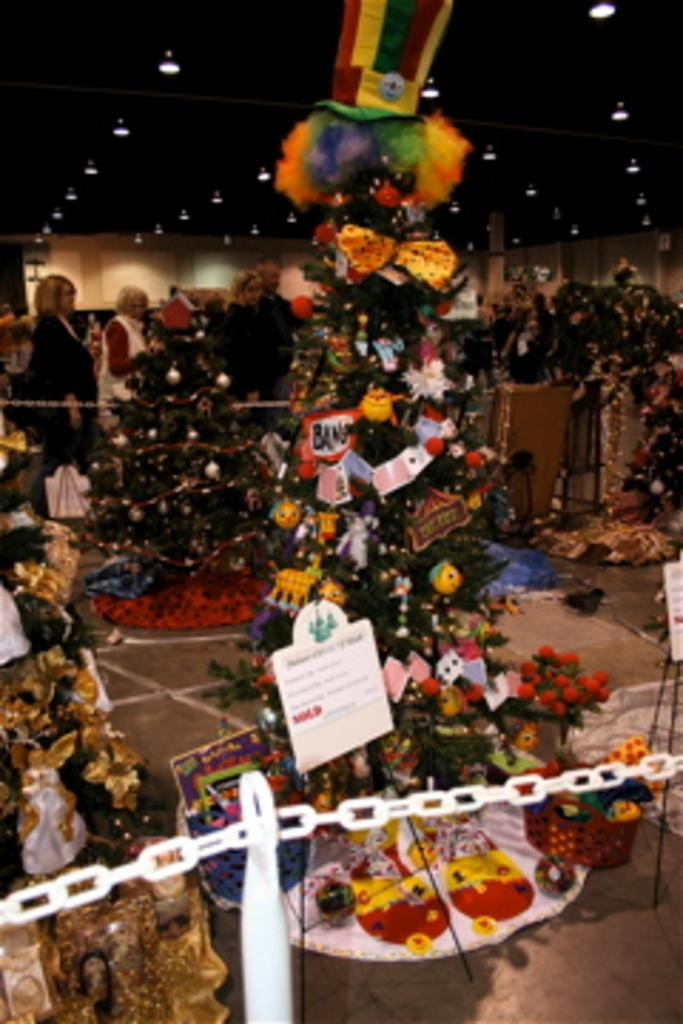How many people are in the group visible in the image? There is a group of people in the image, but the exact number cannot be determined from the provided facts. What is decorating the trees in the image? The trees are decorated with balls, ribbons, and toys. What type of barriers are present in the image? There are boards and chain barriers in the image. What can be seen in the background of the image? Lights are visible in the background of the image. What type of fish can be seen swimming in the image? There is no fish visible in the image; it features a group of people and decorated trees. What is the sister of the person holding the camera doing in the image? There is no mention of a camera or a sister in the provided facts, so it is not possible to answer this question. 